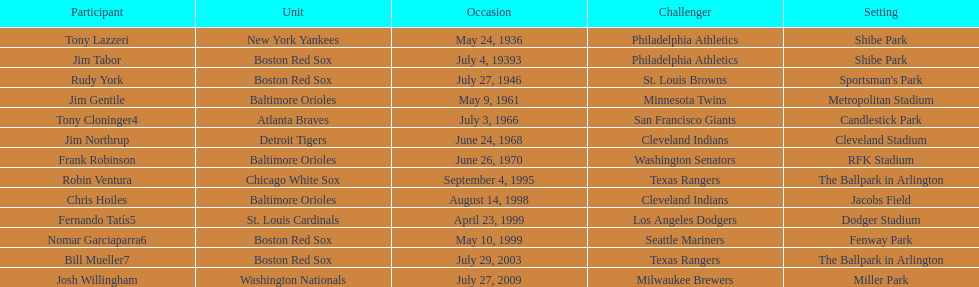Who were all the teams? New York Yankees, Boston Red Sox, Boston Red Sox, Baltimore Orioles, Atlanta Braves, Detroit Tigers, Baltimore Orioles, Chicago White Sox, Baltimore Orioles, St. Louis Cardinals, Boston Red Sox, Boston Red Sox, Washington Nationals. What about opponents? Philadelphia Athletics, Philadelphia Athletics, St. Louis Browns, Minnesota Twins, San Francisco Giants, Cleveland Indians, Washington Senators, Texas Rangers, Cleveland Indians, Los Angeles Dodgers, Seattle Mariners, Texas Rangers, Milwaukee Brewers. And when did they play? May 24, 1936, July 4, 19393, July 27, 1946, May 9, 1961, July 3, 1966, June 24, 1968, June 26, 1970, September 4, 1995, August 14, 1998, April 23, 1999, May 10, 1999, July 29, 2003, July 27, 2009. Which team played the red sox on july 27, 1946	? St. Louis Browns. 